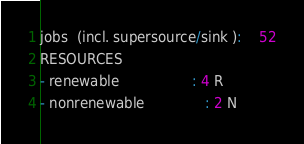<code> <loc_0><loc_0><loc_500><loc_500><_ObjectiveC_>jobs  (incl. supersource/sink ):	52
RESOURCES
- renewable                 : 4 R
- nonrenewable              : 2 N</code> 